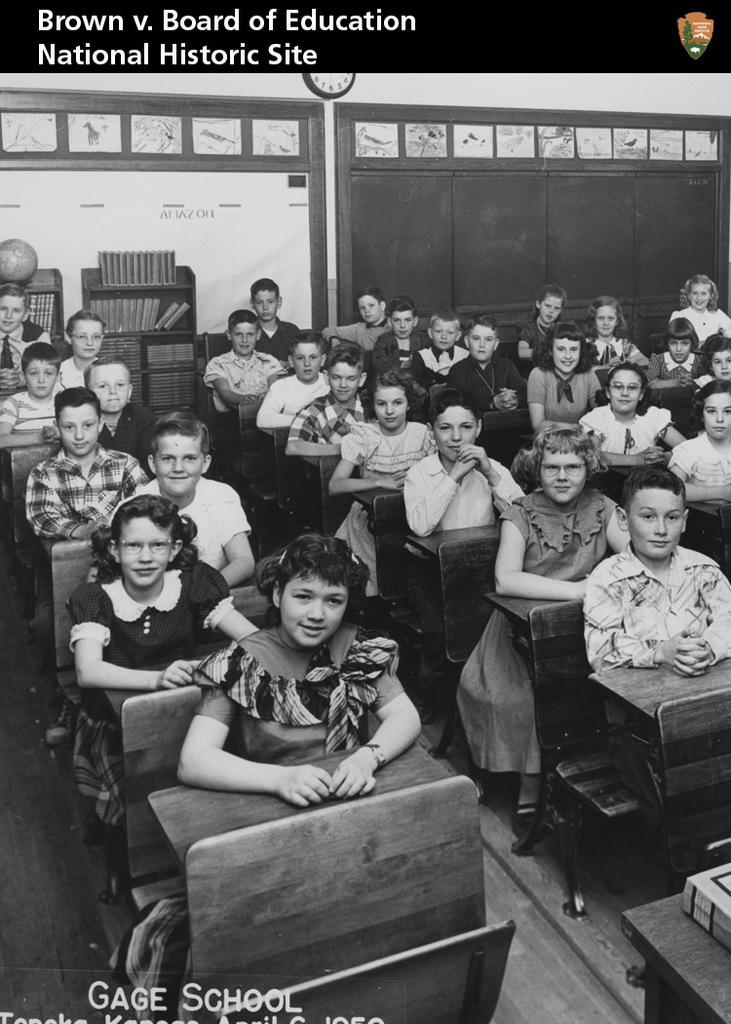What are the children doing in the image? The children are sitting on the benches in the image. What can be found inside the cupboard in the image? There are books and a globe inside the cupboard in the image. What time-telling device is visible in the image? A clock is visible in the image. What type of structure is present in the background of the image? There is a wall in the image. What type of territory is being claimed by the goose in the image? There is no goose present in the image, so no territory is being claimed. How many sticks are being used by the children in the image? There are no sticks visible in the image; the children are sitting on benches. 